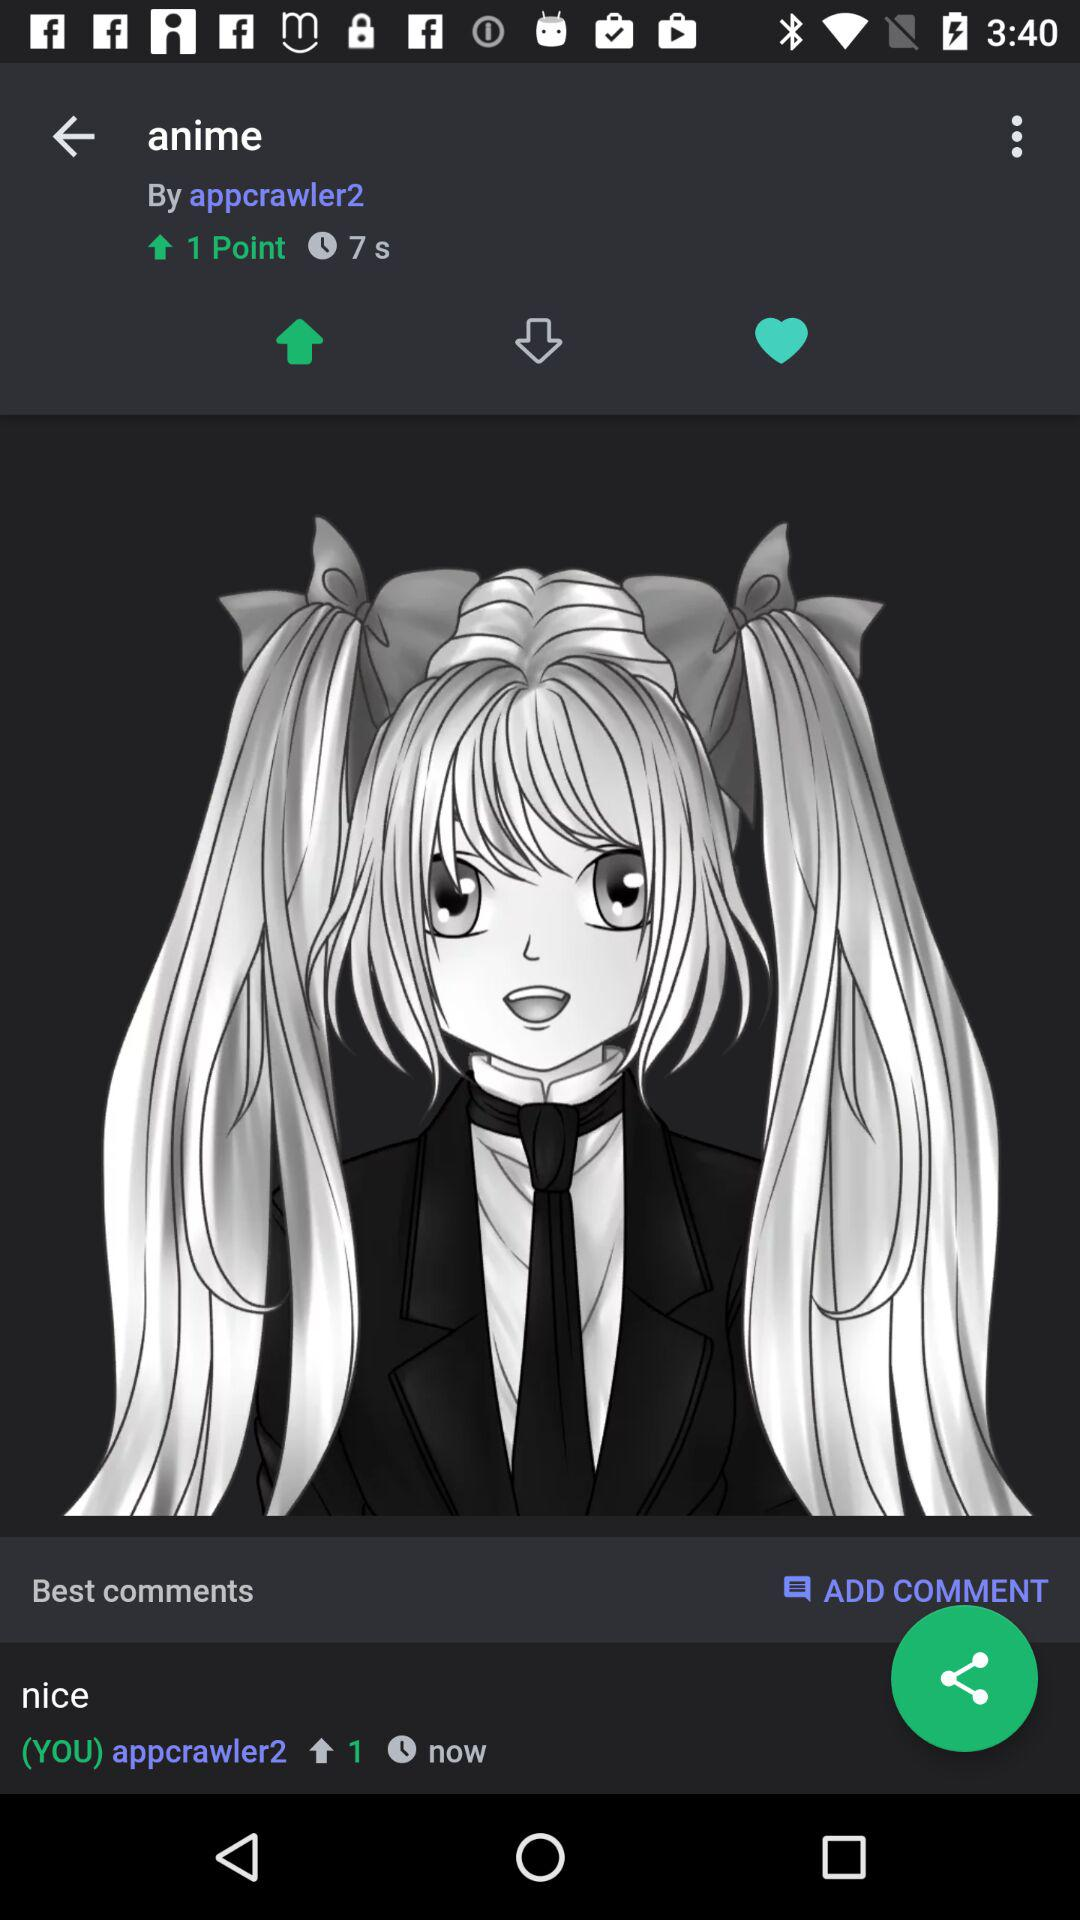What is the name of the user? The name of the user is Appcrawler2. 